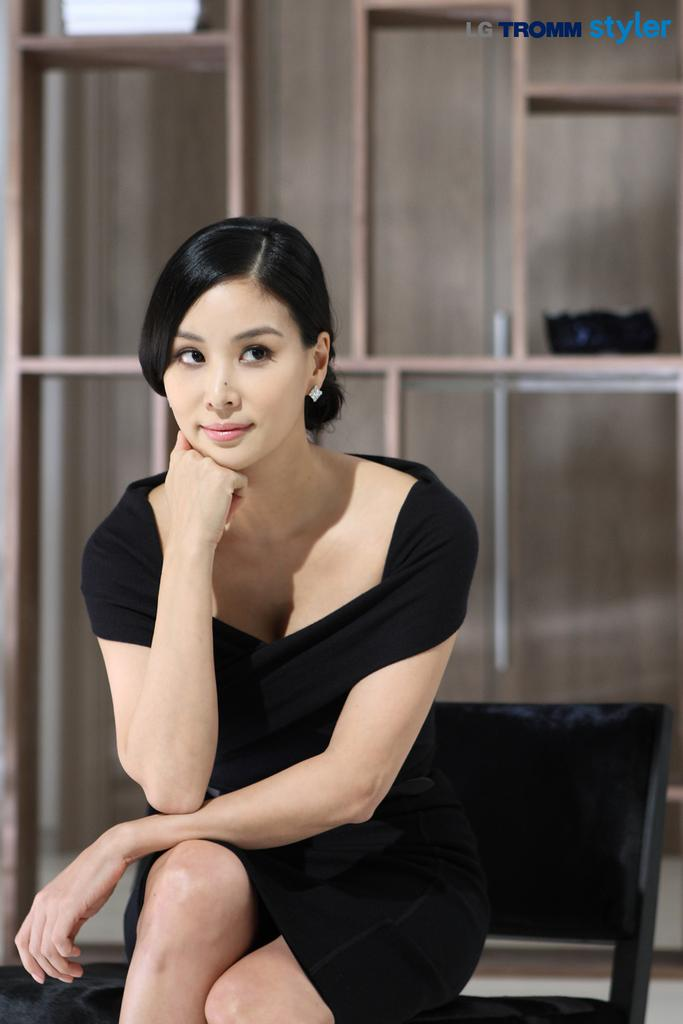Who is the main subject in the image? There is a woman in the image. What is the woman doing in the image? The woman is sitting on a chair. What can be seen in the background of the image? There are objects on shelves in the background of the image. What angle does the appliance have in the image? There is no appliance present in the image. 